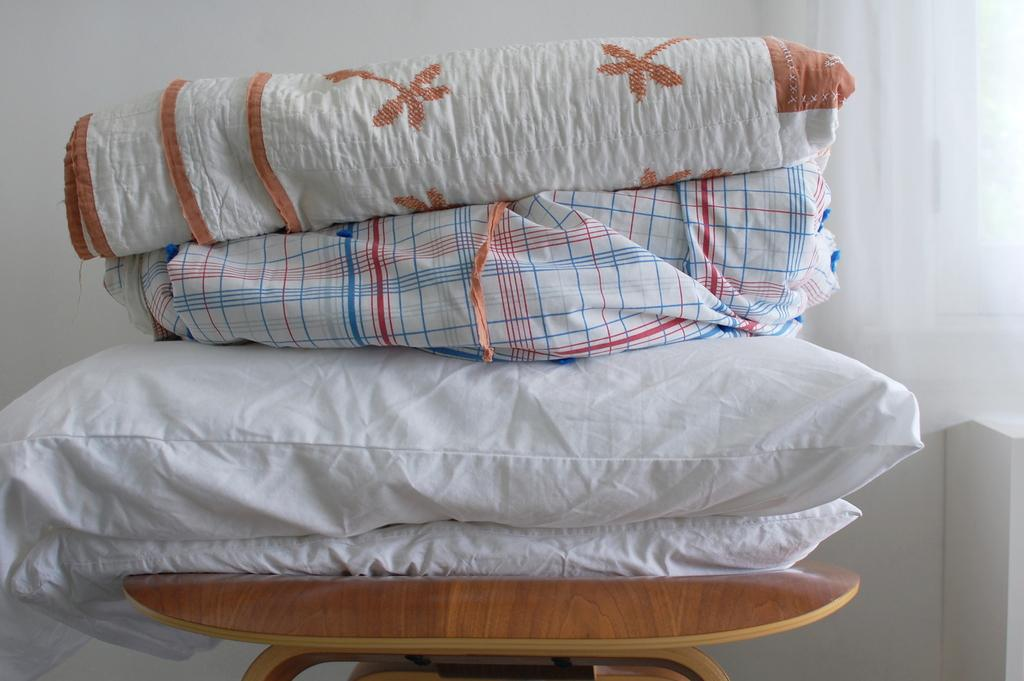What type of soft furnishings are present in the image? There are pillows and blankets in the image. Where are the pillows and blankets located? The pillows and blankets are placed on top of a table. Can you see a cat sitting on top of the pillows in the image? There is no cat present in the image. Is there a light bulb attached to the table in the image? There is no light bulb mentioned or visible in the image. 